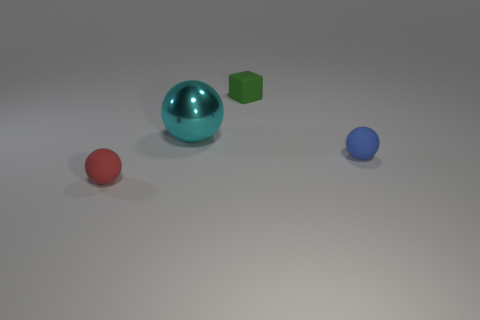How many other objects are the same color as the small cube?
Provide a succinct answer. 0. How many big objects are red matte balls or green objects?
Your answer should be compact. 0. Is the number of small cyan metal cubes greater than the number of objects?
Your response must be concise. No. Does the blue ball have the same material as the cyan ball?
Make the answer very short. No. Is there anything else that is the same material as the big ball?
Offer a very short reply. No. Is the number of tiny things behind the cyan thing greater than the number of red things?
Make the answer very short. No. Is the big ball the same color as the tiny cube?
Provide a succinct answer. No. How many big green objects are the same shape as the tiny red rubber thing?
Offer a very short reply. 0. What size is the block that is the same material as the blue thing?
Provide a short and direct response. Small. There is a small object that is both right of the large sphere and in front of the big cyan thing; what color is it?
Provide a succinct answer. Blue. 